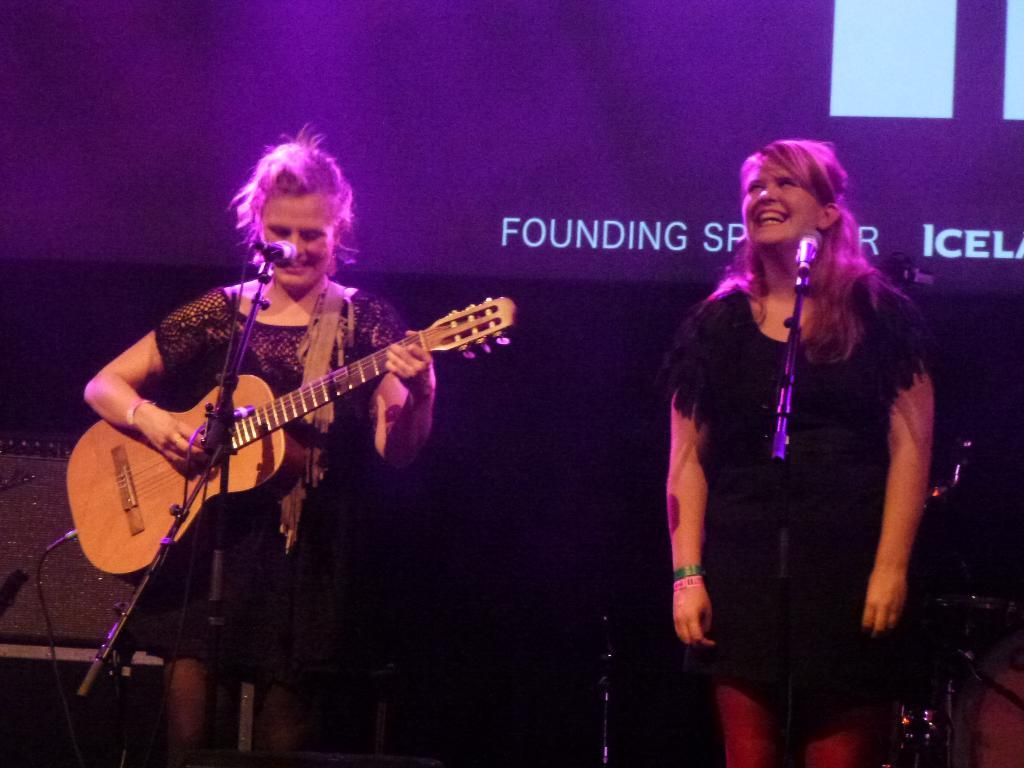How many people are in the image? There are two women in the image. What are the women doing in the image? The women are standing in front of a microphone, and one of them is playing a guitar. Can you describe the facial expression of one of the women? One of the women is smiling. What type of animal can be seen growing in the image? There is no animal or growth present in the image. What mark is visible on the guitar in the image? There is no mark mentioned on the guitar in the provided facts. 